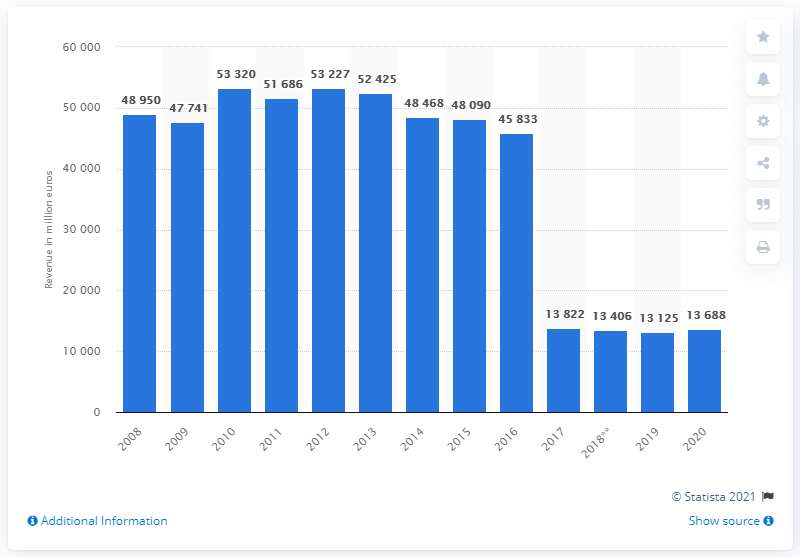Give some essential details in this illustration. RWE generated approximately 13,688 revenue in 2020. 